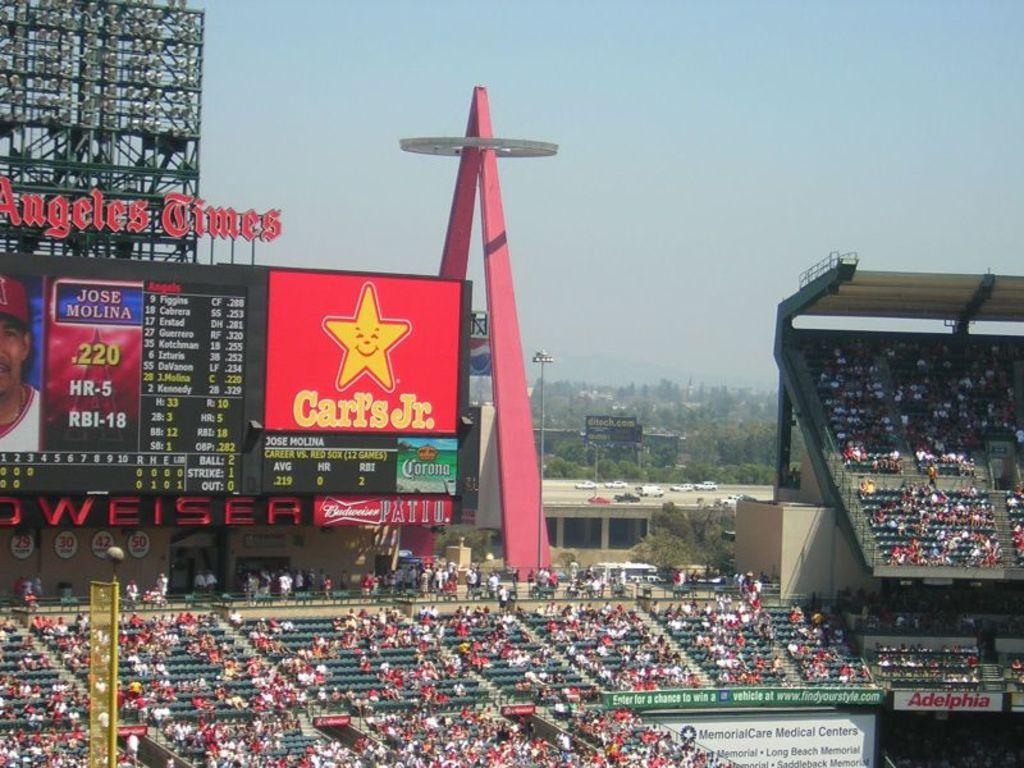<image>
Summarize the visual content of the image. Sports stadium that has an ad for Carls Jr. 